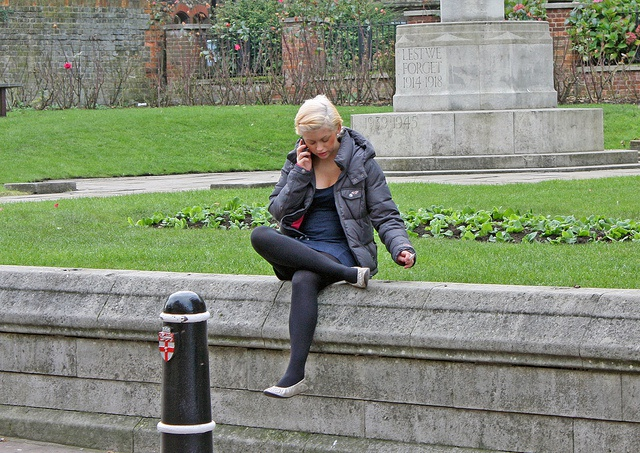Describe the objects in this image and their specific colors. I can see people in gray, black, and darkgray tones and cell phone in gray, black, and maroon tones in this image. 